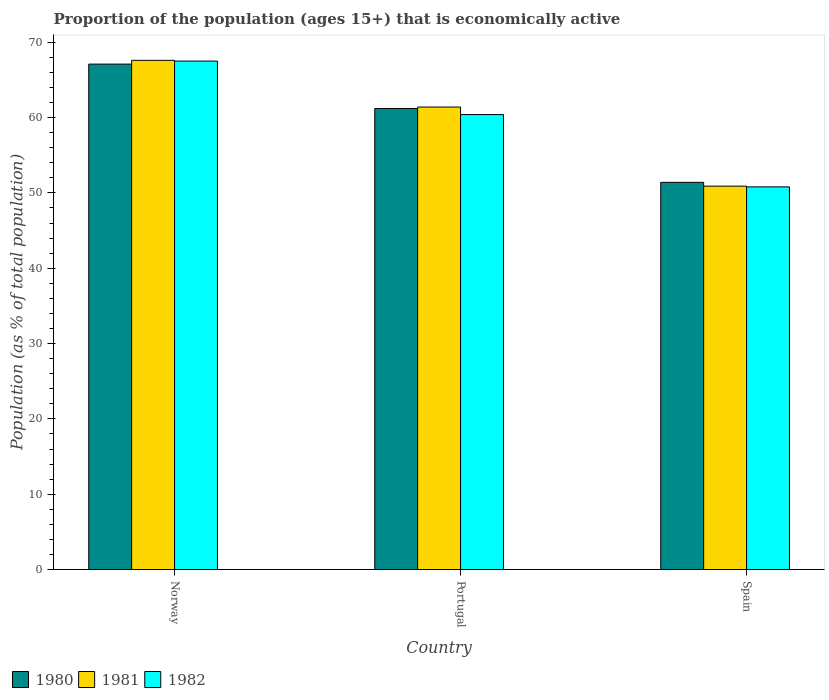How many different coloured bars are there?
Make the answer very short. 3. How many groups of bars are there?
Ensure brevity in your answer.  3. How many bars are there on the 1st tick from the left?
Ensure brevity in your answer.  3. What is the label of the 3rd group of bars from the left?
Give a very brief answer. Spain. What is the proportion of the population that is economically active in 1982 in Spain?
Your answer should be compact. 50.8. Across all countries, what is the maximum proportion of the population that is economically active in 1981?
Give a very brief answer. 67.6. Across all countries, what is the minimum proportion of the population that is economically active in 1981?
Provide a short and direct response. 50.9. What is the total proportion of the population that is economically active in 1981 in the graph?
Your response must be concise. 179.9. What is the difference between the proportion of the population that is economically active in 1982 in Norway and that in Portugal?
Keep it short and to the point. 7.1. What is the difference between the proportion of the population that is economically active in 1980 in Spain and the proportion of the population that is economically active in 1981 in Norway?
Your response must be concise. -16.2. What is the average proportion of the population that is economically active in 1980 per country?
Provide a succinct answer. 59.9. What is the difference between the proportion of the population that is economically active of/in 1980 and proportion of the population that is economically active of/in 1981 in Norway?
Keep it short and to the point. -0.5. What is the ratio of the proportion of the population that is economically active in 1981 in Norway to that in Spain?
Your answer should be compact. 1.33. Is the difference between the proportion of the population that is economically active in 1980 in Norway and Spain greater than the difference between the proportion of the population that is economically active in 1981 in Norway and Spain?
Make the answer very short. No. What is the difference between the highest and the second highest proportion of the population that is economically active in 1981?
Keep it short and to the point. -16.7. What is the difference between the highest and the lowest proportion of the population that is economically active in 1981?
Your response must be concise. 16.7. Is the sum of the proportion of the population that is economically active in 1982 in Norway and Spain greater than the maximum proportion of the population that is economically active in 1981 across all countries?
Provide a succinct answer. Yes. What does the 3rd bar from the left in Portugal represents?
Ensure brevity in your answer.  1982. What does the 3rd bar from the right in Spain represents?
Provide a short and direct response. 1980. How many countries are there in the graph?
Keep it short and to the point. 3. What is the difference between two consecutive major ticks on the Y-axis?
Keep it short and to the point. 10. Are the values on the major ticks of Y-axis written in scientific E-notation?
Keep it short and to the point. No. Does the graph contain grids?
Your answer should be very brief. No. How are the legend labels stacked?
Offer a terse response. Horizontal. What is the title of the graph?
Your answer should be compact. Proportion of the population (ages 15+) that is economically active. Does "1962" appear as one of the legend labels in the graph?
Offer a terse response. No. What is the label or title of the X-axis?
Make the answer very short. Country. What is the label or title of the Y-axis?
Ensure brevity in your answer.  Population (as % of total population). What is the Population (as % of total population) of 1980 in Norway?
Offer a terse response. 67.1. What is the Population (as % of total population) in 1981 in Norway?
Offer a terse response. 67.6. What is the Population (as % of total population) in 1982 in Norway?
Keep it short and to the point. 67.5. What is the Population (as % of total population) of 1980 in Portugal?
Offer a terse response. 61.2. What is the Population (as % of total population) of 1981 in Portugal?
Give a very brief answer. 61.4. What is the Population (as % of total population) in 1982 in Portugal?
Give a very brief answer. 60.4. What is the Population (as % of total population) in 1980 in Spain?
Offer a very short reply. 51.4. What is the Population (as % of total population) in 1981 in Spain?
Offer a terse response. 50.9. What is the Population (as % of total population) of 1982 in Spain?
Make the answer very short. 50.8. Across all countries, what is the maximum Population (as % of total population) of 1980?
Your answer should be very brief. 67.1. Across all countries, what is the maximum Population (as % of total population) of 1981?
Your response must be concise. 67.6. Across all countries, what is the maximum Population (as % of total population) of 1982?
Offer a terse response. 67.5. Across all countries, what is the minimum Population (as % of total population) in 1980?
Offer a terse response. 51.4. Across all countries, what is the minimum Population (as % of total population) of 1981?
Keep it short and to the point. 50.9. Across all countries, what is the minimum Population (as % of total population) in 1982?
Give a very brief answer. 50.8. What is the total Population (as % of total population) of 1980 in the graph?
Your answer should be compact. 179.7. What is the total Population (as % of total population) in 1981 in the graph?
Make the answer very short. 179.9. What is the total Population (as % of total population) of 1982 in the graph?
Ensure brevity in your answer.  178.7. What is the difference between the Population (as % of total population) in 1981 in Norway and that in Portugal?
Your response must be concise. 6.2. What is the difference between the Population (as % of total population) of 1982 in Norway and that in Portugal?
Ensure brevity in your answer.  7.1. What is the difference between the Population (as % of total population) in 1980 in Norway and that in Spain?
Your answer should be compact. 15.7. What is the difference between the Population (as % of total population) in 1981 in Portugal and that in Spain?
Your answer should be very brief. 10.5. What is the difference between the Population (as % of total population) in 1982 in Portugal and that in Spain?
Your answer should be compact. 9.6. What is the difference between the Population (as % of total population) of 1981 in Norway and the Population (as % of total population) of 1982 in Portugal?
Give a very brief answer. 7.2. What is the average Population (as % of total population) in 1980 per country?
Your answer should be compact. 59.9. What is the average Population (as % of total population) in 1981 per country?
Keep it short and to the point. 59.97. What is the average Population (as % of total population) in 1982 per country?
Keep it short and to the point. 59.57. What is the difference between the Population (as % of total population) in 1981 and Population (as % of total population) in 1982 in Norway?
Keep it short and to the point. 0.1. What is the difference between the Population (as % of total population) in 1980 and Population (as % of total population) in 1981 in Spain?
Provide a succinct answer. 0.5. What is the difference between the Population (as % of total population) of 1981 and Population (as % of total population) of 1982 in Spain?
Give a very brief answer. 0.1. What is the ratio of the Population (as % of total population) in 1980 in Norway to that in Portugal?
Keep it short and to the point. 1.1. What is the ratio of the Population (as % of total population) in 1981 in Norway to that in Portugal?
Offer a very short reply. 1.1. What is the ratio of the Population (as % of total population) in 1982 in Norway to that in Portugal?
Your answer should be compact. 1.12. What is the ratio of the Population (as % of total population) of 1980 in Norway to that in Spain?
Make the answer very short. 1.31. What is the ratio of the Population (as % of total population) of 1981 in Norway to that in Spain?
Offer a terse response. 1.33. What is the ratio of the Population (as % of total population) of 1982 in Norway to that in Spain?
Provide a short and direct response. 1.33. What is the ratio of the Population (as % of total population) in 1980 in Portugal to that in Spain?
Offer a terse response. 1.19. What is the ratio of the Population (as % of total population) of 1981 in Portugal to that in Spain?
Your response must be concise. 1.21. What is the ratio of the Population (as % of total population) of 1982 in Portugal to that in Spain?
Your answer should be compact. 1.19. What is the difference between the highest and the second highest Population (as % of total population) in 1981?
Your response must be concise. 6.2. What is the difference between the highest and the lowest Population (as % of total population) in 1982?
Your answer should be compact. 16.7. 